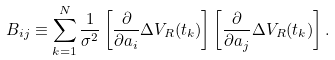<formula> <loc_0><loc_0><loc_500><loc_500>B _ { i j } \equiv \sum _ { k = 1 } ^ { N } \frac { 1 } { \sigma ^ { 2 } } \left [ \frac { \partial } { \partial a _ { i } } \Delta V _ { R } ( t _ { k } ) \right ] \left [ \frac { \partial } { \partial a _ { j } } \Delta V _ { R } ( t _ { k } ) \right ] .</formula> 